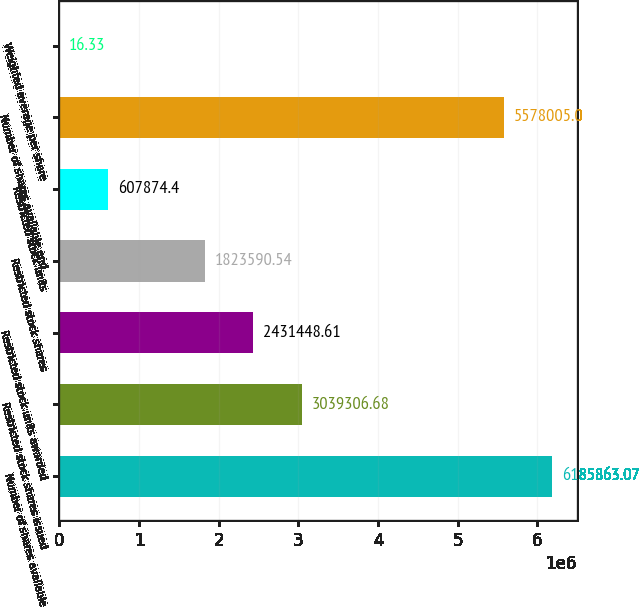<chart> <loc_0><loc_0><loc_500><loc_500><bar_chart><fcel>Number of shares available<fcel>Restricted stock shares issued<fcel>Restricted stock units awarded<fcel>Restricted stock shares<fcel>Restricted stock units<fcel>Number of shares available end<fcel>Weighted average per share<nl><fcel>6.18586e+06<fcel>3.03931e+06<fcel>2.43145e+06<fcel>1.82359e+06<fcel>607874<fcel>5.578e+06<fcel>16.33<nl></chart> 